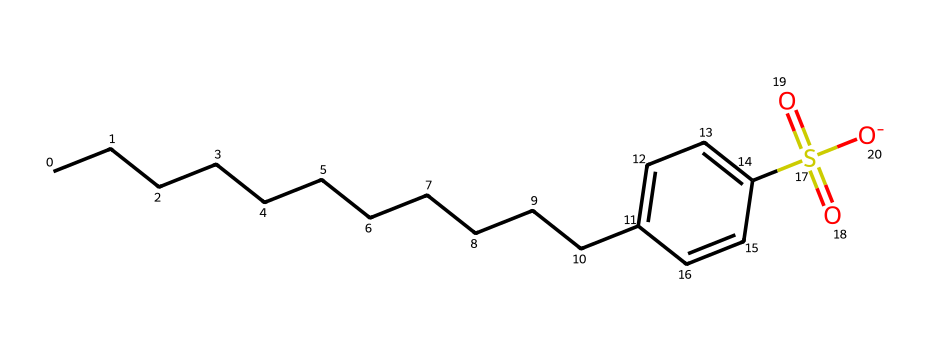What is the main functional group in alkylbenzene sulfonate? The chemical contains the sulfonate group, represented by the S(=O)(=O)[O-] portion of the structure. This indicates the presence of sulfur and oxygen, characteristic of sulfonates.
Answer: sulfonate How many carbon atoms are in the alkyl chain of this compound? By counting the 'C' symbols, the alkyl chain consists of 12 carbon atoms before reaching the benzene ring, denoting the long carbon tail typical of alkyl groups.
Answer: 12 What type of bonding is primarily involved in the alkylbenzene sulfonate structure? The structure includes covalent bonding, particularly between carbon and sulfur atoms as well as within the carbon chain, which is typical for organic compounds like detergents.
Answer: covalent Which part of the molecule is hydrophilic? The sulfonate group (S(=O)(=O)[O-]) has strong affinity for water and contributes to the hydrophilic nature of the compound, allowing it to interact with polar solvents.
Answer: sulfonate group What property does the  aromatic ring provide to alkylbenzene sulfonate? The aromatic ring enhances the overall structural stability and provides a degree of hydrophobicity, balancing the hydrophilic sulfonate group for better surfactant action in detergents.
Answer: stability and hydrophobicity 